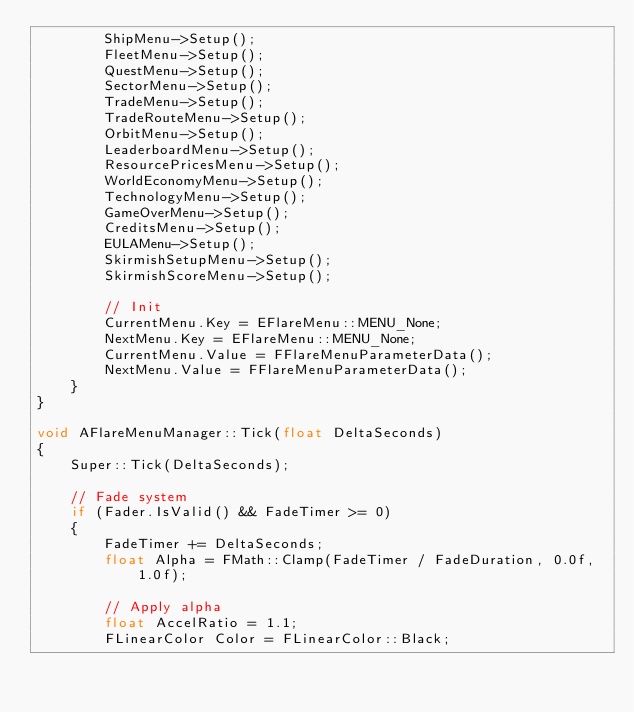Convert code to text. <code><loc_0><loc_0><loc_500><loc_500><_C++_>		ShipMenu->Setup();
		FleetMenu->Setup();
		QuestMenu->Setup();
		SectorMenu->Setup();
		TradeMenu->Setup();
		TradeRouteMenu->Setup();
		OrbitMenu->Setup();
		LeaderboardMenu->Setup();
		ResourcePricesMenu->Setup();
		WorldEconomyMenu->Setup();
		TechnologyMenu->Setup();
		GameOverMenu->Setup();
		CreditsMenu->Setup();
		EULAMenu->Setup();
		SkirmishSetupMenu->Setup();
		SkirmishScoreMenu->Setup();

		// Init
		CurrentMenu.Key = EFlareMenu::MENU_None;
		NextMenu.Key = EFlareMenu::MENU_None;
		CurrentMenu.Value = FFlareMenuParameterData();
		NextMenu.Value = FFlareMenuParameterData();
	}
}

void AFlareMenuManager::Tick(float DeltaSeconds)
{
	Super::Tick(DeltaSeconds);

	// Fade system
	if (Fader.IsValid() && FadeTimer >= 0)
	{
		FadeTimer += DeltaSeconds;
		float Alpha = FMath::Clamp(FadeTimer / FadeDuration, 0.0f, 1.0f);

		// Apply alpha
		float AccelRatio = 1.1;
		FLinearColor Color = FLinearColor::Black;</code> 